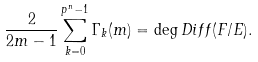<formula> <loc_0><loc_0><loc_500><loc_500>\frac { 2 } { 2 m - 1 } \sum _ { k = 0 } ^ { p ^ { n } - 1 } \Gamma _ { k } ( m ) = \deg D i f f ( F / E ) .</formula> 